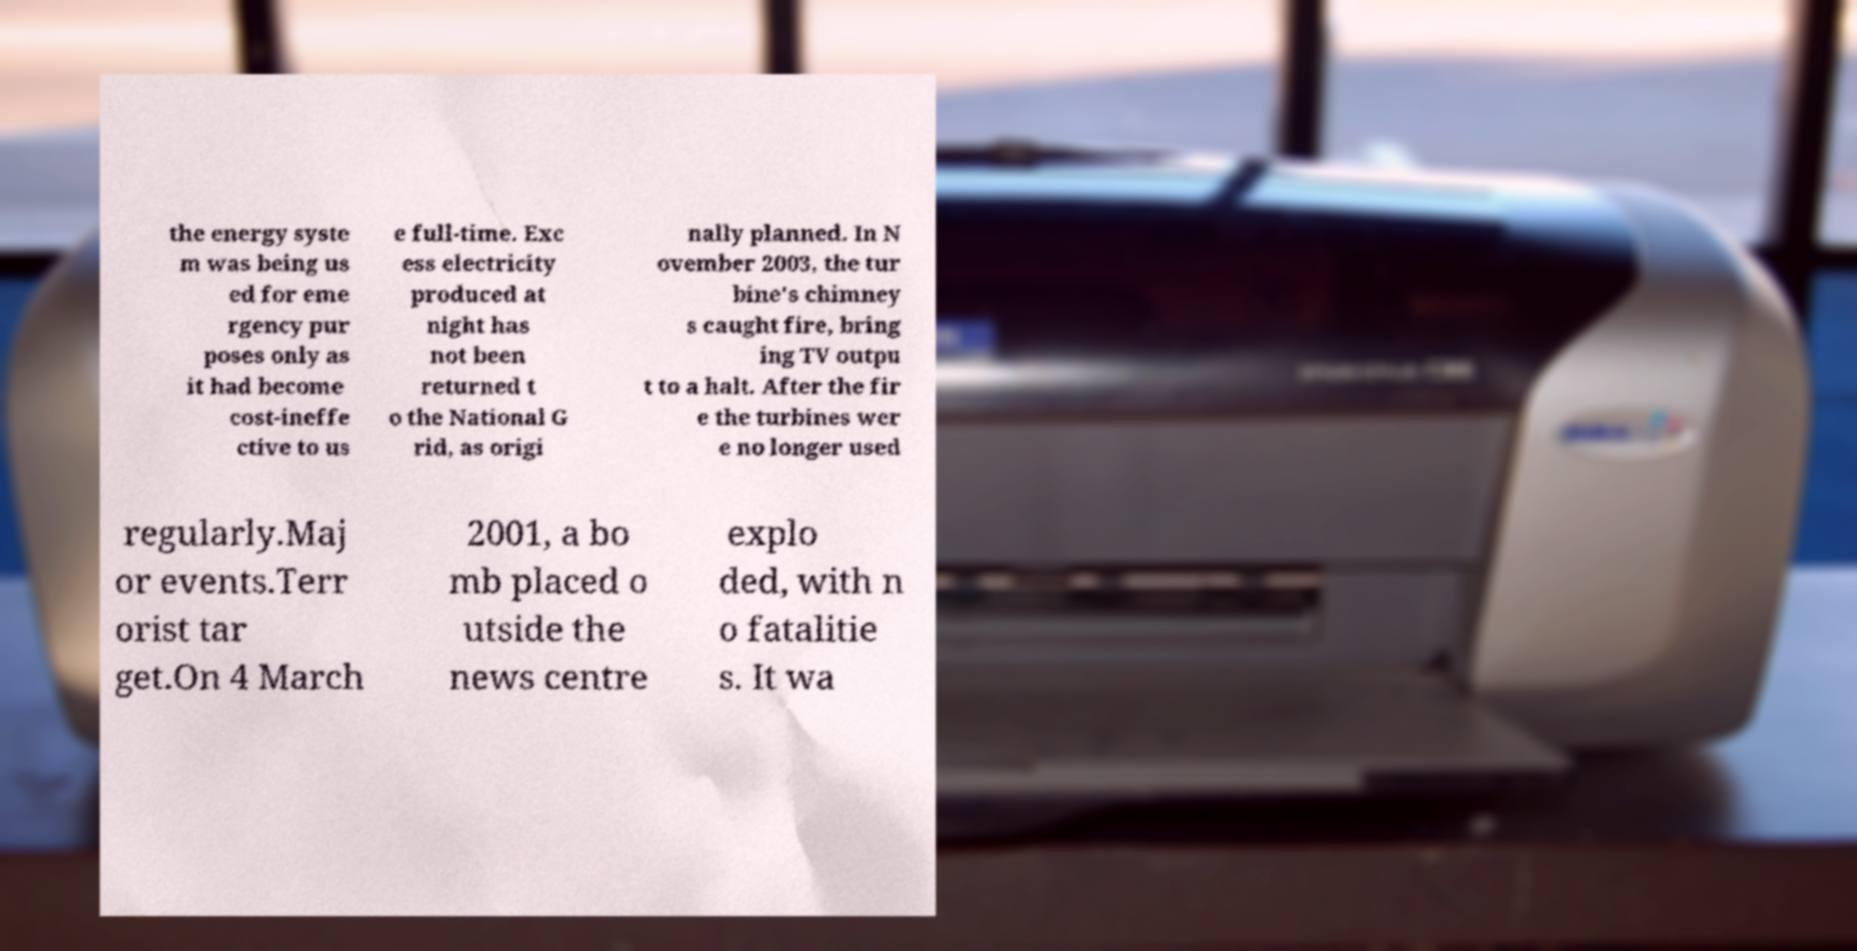Could you assist in decoding the text presented in this image and type it out clearly? the energy syste m was being us ed for eme rgency pur poses only as it had become cost-ineffe ctive to us e full-time. Exc ess electricity produced at night has not been returned t o the National G rid, as origi nally planned. In N ovember 2003, the tur bine's chimney s caught fire, bring ing TV outpu t to a halt. After the fir e the turbines wer e no longer used regularly.Maj or events.Terr orist tar get.On 4 March 2001, a bo mb placed o utside the news centre explo ded, with n o fatalitie s. It wa 